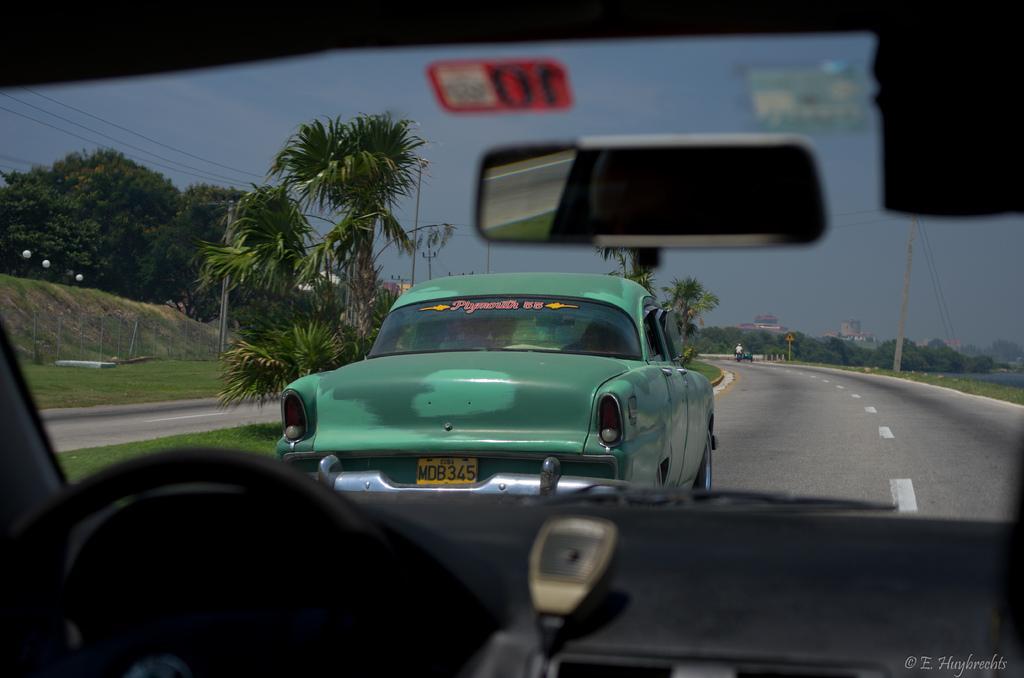Describe this image in one or two sentences. In this image I can see the vehicles on the road. On both sides of the road I can see the poles and many trees. In the background I can see the buildings and the sky. 